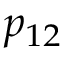Convert formula to latex. <formula><loc_0><loc_0><loc_500><loc_500>p _ { 1 2 }</formula> 